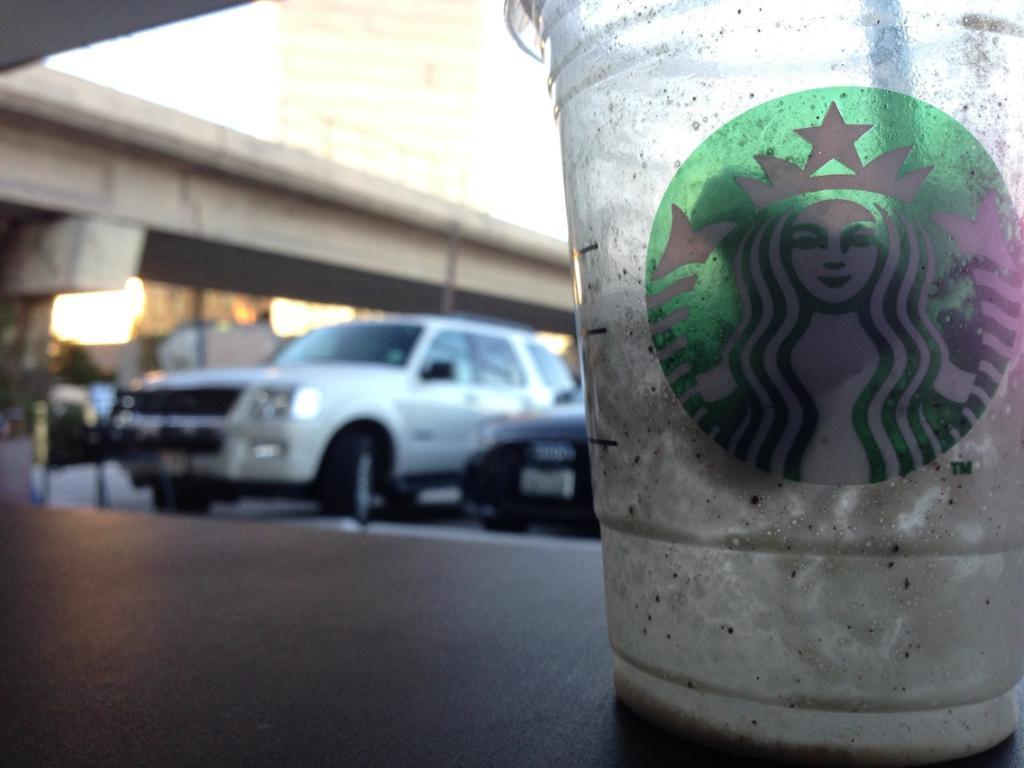What object is present on a platform in the image? There is a cup on a platform in the image. Can you describe the surroundings of the cup? The background of the image is blurry. What else can be seen in the image besides the cup? There are vehicles visible in the background of the image. How many jellyfish are swimming in the cup in the image? There are no jellyfish present in the image; it only features a cup on a platform. 